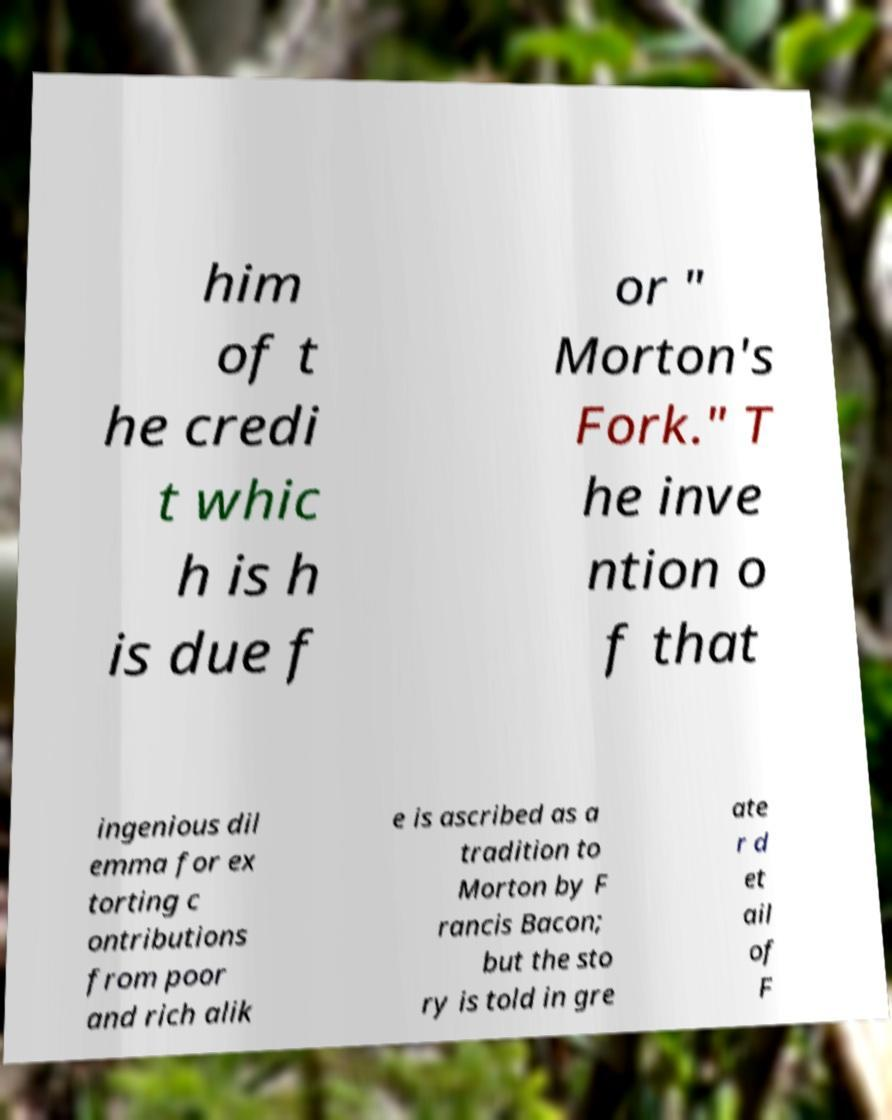I need the written content from this picture converted into text. Can you do that? him of t he credi t whic h is h is due f or " Morton's Fork." T he inve ntion o f that ingenious dil emma for ex torting c ontributions from poor and rich alik e is ascribed as a tradition to Morton by F rancis Bacon; but the sto ry is told in gre ate r d et ail of F 